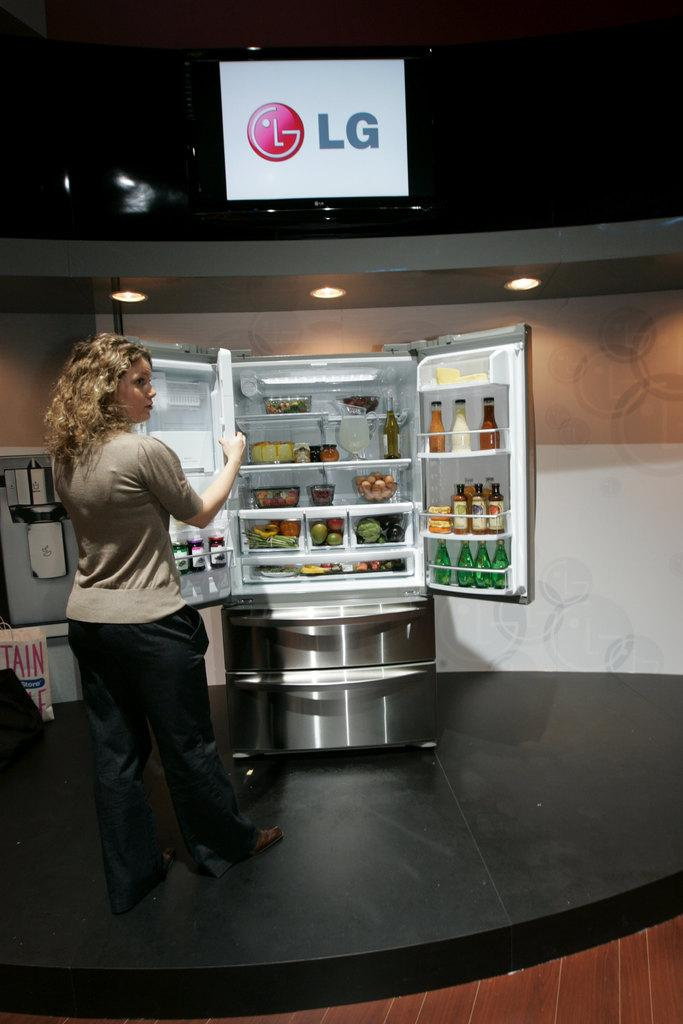Provide a one-sentence caption for the provided image. A woman is in front of an opened refrigerator under the sign that says LG. 